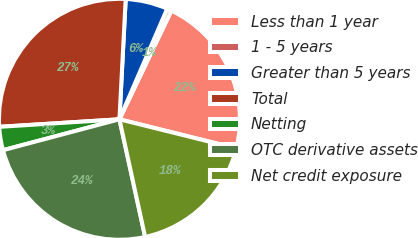<chart> <loc_0><loc_0><loc_500><loc_500><pie_chart><fcel>Less than 1 year<fcel>1 - 5 years<fcel>Greater than 5 years<fcel>Total<fcel>Netting<fcel>OTC derivative assets<fcel>Net credit exposure<nl><fcel>21.78%<fcel>0.61%<fcel>5.66%<fcel>26.83%<fcel>3.13%<fcel>24.3%<fcel>17.7%<nl></chart> 